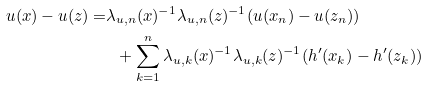<formula> <loc_0><loc_0><loc_500><loc_500>u ( x ) - u ( z ) = & \lambda _ { u , n } ( x ) ^ { - 1 } \lambda _ { u , n } ( z ) ^ { - 1 } ( u ( x _ { n } ) - u ( z _ { n } ) ) \\ & \ \ + \sum _ { k = 1 } ^ { n } \lambda _ { u , k } ( x ) ^ { - 1 } \lambda _ { u , k } ( z ) ^ { - 1 } ( h ^ { \prime } ( x _ { k } ) - h ^ { \prime } ( z _ { k } ) )</formula> 